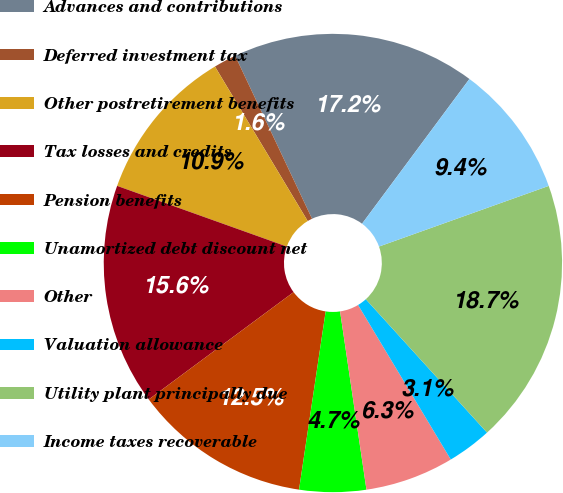Convert chart to OTSL. <chart><loc_0><loc_0><loc_500><loc_500><pie_chart><fcel>Advances and contributions<fcel>Deferred investment tax<fcel>Other postretirement benefits<fcel>Tax losses and credits<fcel>Pension benefits<fcel>Unamortized debt discount net<fcel>Other<fcel>Valuation allowance<fcel>Utility plant principally due<fcel>Income taxes recoverable<nl><fcel>17.17%<fcel>1.59%<fcel>10.93%<fcel>15.61%<fcel>12.49%<fcel>4.7%<fcel>6.26%<fcel>3.14%<fcel>18.72%<fcel>9.38%<nl></chart> 